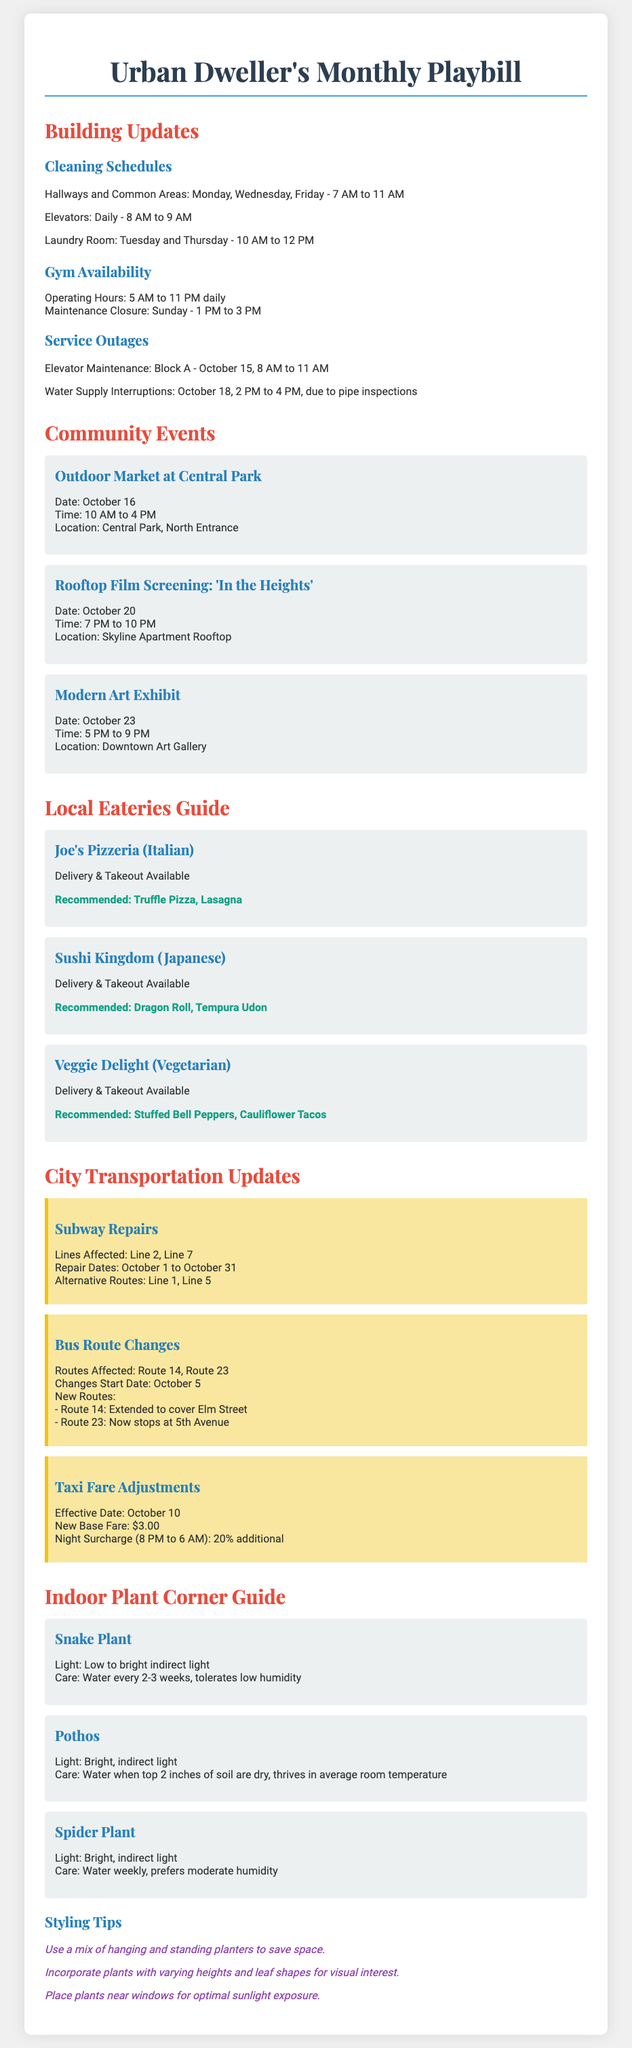What days are hallways and common areas cleaned? The cleaning schedule mentions that hallways and common areas are cleaned on Monday, Wednesday, and Friday.
Answer: Monday, Wednesday, Friday What time does the gym close on Sundays? The gym's maintenance closure on Sunday is listed from 1 PM to 3 PM, thus closing at 3 PM.
Answer: 3 PM When is the outdoor market taking place? The document states the outdoor market at Central Park is on October 16.
Answer: October 16 What is the recommended dish at Sushi Kingdom? The document highlights that the recommended dish at Sushi Kingdom is the Dragon Roll.
Answer: Dragon Roll Which subway lines are affected by repairs? The subway transportation updates state that Line 2 and Line 7 are affected by repairs.
Answer: Line 2, Line 7 How often should the Snake Plant be watered? The care instructions for the Snake Plant indicate it should be watered every 2-3 weeks.
Answer: every 2-3 weeks What type of event is scheduled for October 20? The event scheduled for October 20 is a rooftop film screening.
Answer: rooftop film screening What is the new base fare for taxis effective October 10? The taxi fare adjustments indicate that the new base fare is $3.00.
Answer: $3.00 What styling tips are provided for indoor plants? The document lists a series of tips, such as using a mix of hanging and standing planters.
Answer: Use a mix of hanging and standing planters 